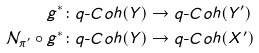<formula> <loc_0><loc_0><loc_500><loc_500>g ^ { \ast } & \colon q \text {-} C o h ( Y ) \rightarrow q \text {-} C o h ( Y ^ { \prime } ) \\ \mathcal { N } _ { \pi ^ { \prime } } \circ g ^ { \ast } & \colon q \text {-} C o h ( Y ) \rightarrow q \text {-} C o h ( X ^ { \prime } )</formula> 